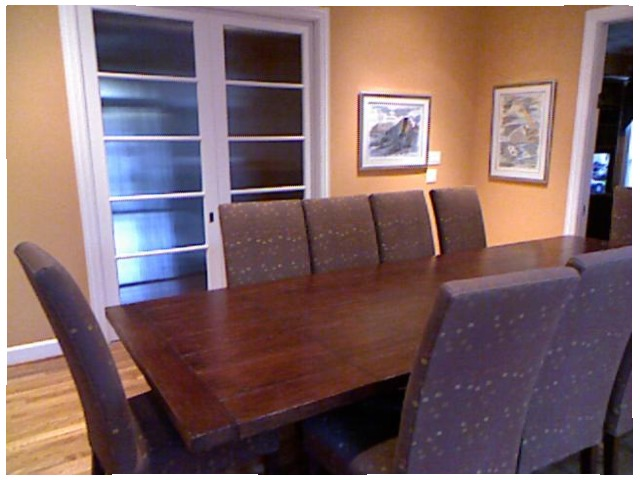<image>
Is there a chair under the table? Yes. The chair is positioned underneath the table, with the table above it in the vertical space. Is the chairs under the table? Yes. The chairs is positioned underneath the table, with the table above it in the vertical space. Is there a chair under the table? Yes. The chair is positioned underneath the table, with the table above it in the vertical space. Is there a table under the floor? No. The table is not positioned under the floor. The vertical relationship between these objects is different. 